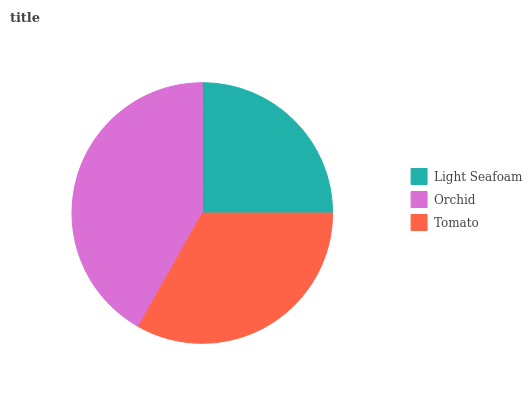Is Light Seafoam the minimum?
Answer yes or no. Yes. Is Orchid the maximum?
Answer yes or no. Yes. Is Tomato the minimum?
Answer yes or no. No. Is Tomato the maximum?
Answer yes or no. No. Is Orchid greater than Tomato?
Answer yes or no. Yes. Is Tomato less than Orchid?
Answer yes or no. Yes. Is Tomato greater than Orchid?
Answer yes or no. No. Is Orchid less than Tomato?
Answer yes or no. No. Is Tomato the high median?
Answer yes or no. Yes. Is Tomato the low median?
Answer yes or no. Yes. Is Orchid the high median?
Answer yes or no. No. Is Light Seafoam the low median?
Answer yes or no. No. 